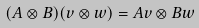Convert formula to latex. <formula><loc_0><loc_0><loc_500><loc_500>( A \otimes B ) ( v \otimes w ) = A v \otimes B w</formula> 